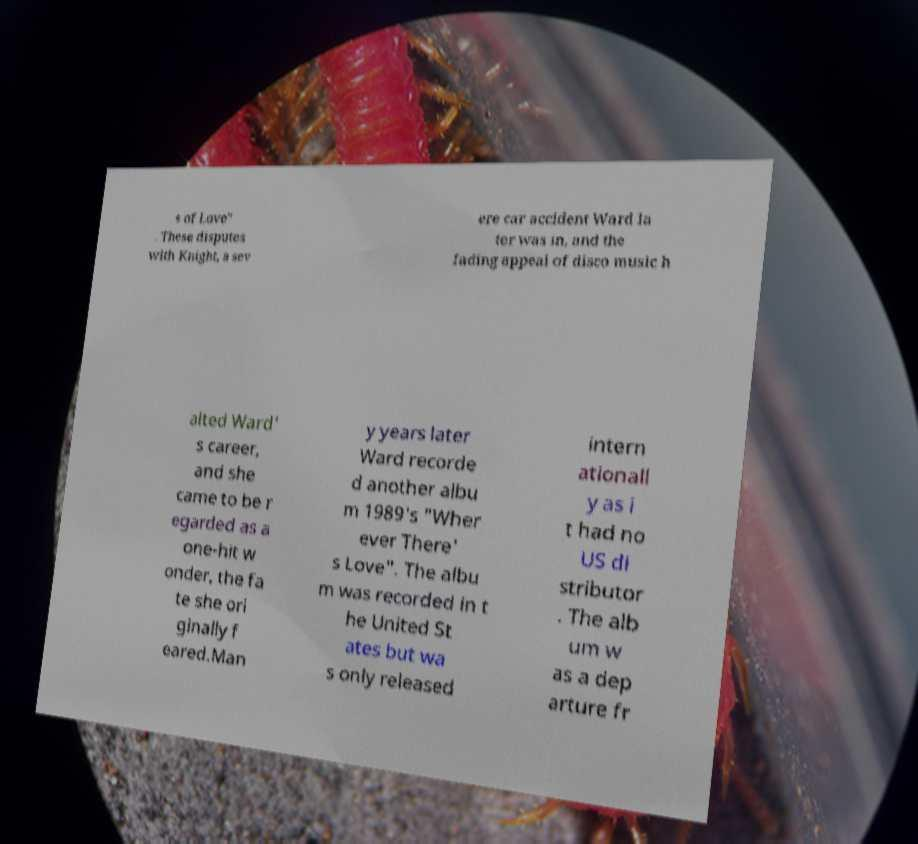Could you assist in decoding the text presented in this image and type it out clearly? s of Love" . These disputes with Knight, a sev ere car accident Ward la ter was in, and the fading appeal of disco music h alted Ward' s career, and she came to be r egarded as a one-hit w onder, the fa te she ori ginally f eared.Man y years later Ward recorde d another albu m 1989's "Wher ever There' s Love". The albu m was recorded in t he United St ates but wa s only released intern ationall y as i t had no US di stributor . The alb um w as a dep arture fr 